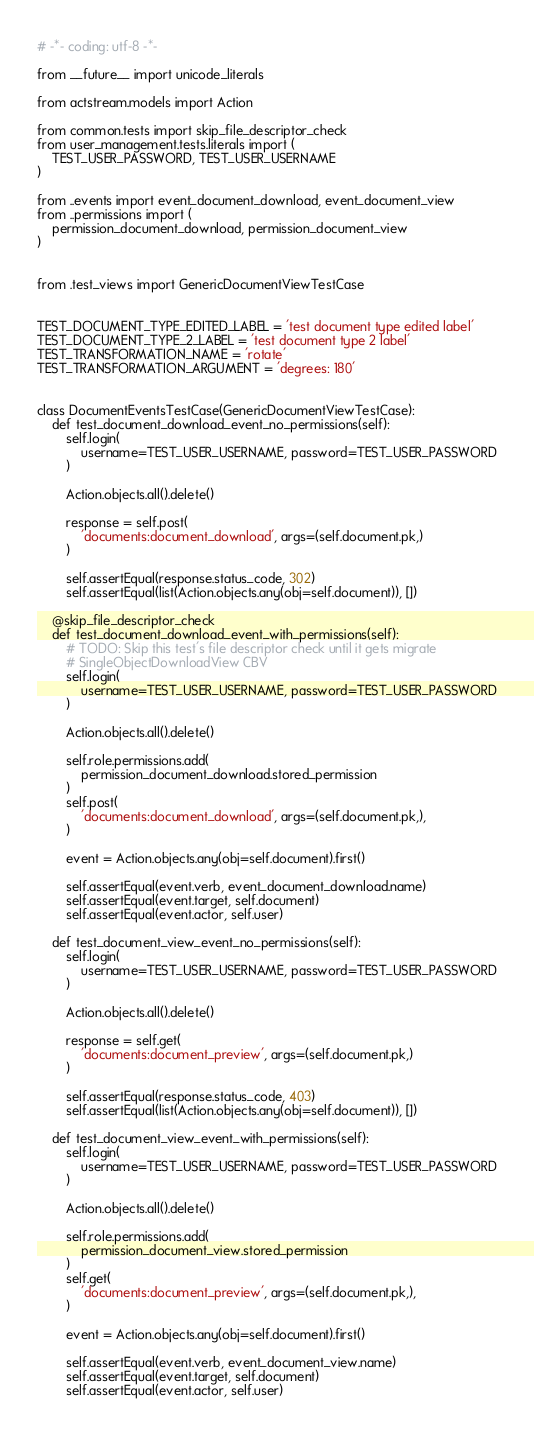Convert code to text. <code><loc_0><loc_0><loc_500><loc_500><_Python_># -*- coding: utf-8 -*-

from __future__ import unicode_literals

from actstream.models import Action

from common.tests import skip_file_descriptor_check
from user_management.tests.literals import (
    TEST_USER_PASSWORD, TEST_USER_USERNAME
)

from ..events import event_document_download, event_document_view
from ..permissions import (
    permission_document_download, permission_document_view
)


from .test_views import GenericDocumentViewTestCase


TEST_DOCUMENT_TYPE_EDITED_LABEL = 'test document type edited label'
TEST_DOCUMENT_TYPE_2_LABEL = 'test document type 2 label'
TEST_TRANSFORMATION_NAME = 'rotate'
TEST_TRANSFORMATION_ARGUMENT = 'degrees: 180'


class DocumentEventsTestCase(GenericDocumentViewTestCase):
    def test_document_download_event_no_permissions(self):
        self.login(
            username=TEST_USER_USERNAME, password=TEST_USER_PASSWORD
        )

        Action.objects.all().delete()

        response = self.post(
            'documents:document_download', args=(self.document.pk,)
        )

        self.assertEqual(response.status_code, 302)
        self.assertEqual(list(Action.objects.any(obj=self.document)), [])

    @skip_file_descriptor_check
    def test_document_download_event_with_permissions(self):
        # TODO: Skip this test's file descriptor check until it gets migrate
        # SingleObjectDownloadView CBV
        self.login(
            username=TEST_USER_USERNAME, password=TEST_USER_PASSWORD
        )

        Action.objects.all().delete()

        self.role.permissions.add(
            permission_document_download.stored_permission
        )
        self.post(
            'documents:document_download', args=(self.document.pk,),
        )

        event = Action.objects.any(obj=self.document).first()

        self.assertEqual(event.verb, event_document_download.name)
        self.assertEqual(event.target, self.document)
        self.assertEqual(event.actor, self.user)

    def test_document_view_event_no_permissions(self):
        self.login(
            username=TEST_USER_USERNAME, password=TEST_USER_PASSWORD
        )

        Action.objects.all().delete()

        response = self.get(
            'documents:document_preview', args=(self.document.pk,)
        )

        self.assertEqual(response.status_code, 403)
        self.assertEqual(list(Action.objects.any(obj=self.document)), [])

    def test_document_view_event_with_permissions(self):
        self.login(
            username=TEST_USER_USERNAME, password=TEST_USER_PASSWORD
        )

        Action.objects.all().delete()

        self.role.permissions.add(
            permission_document_view.stored_permission
        )
        self.get(
            'documents:document_preview', args=(self.document.pk,),
        )

        event = Action.objects.any(obj=self.document).first()

        self.assertEqual(event.verb, event_document_view.name)
        self.assertEqual(event.target, self.document)
        self.assertEqual(event.actor, self.user)
</code> 